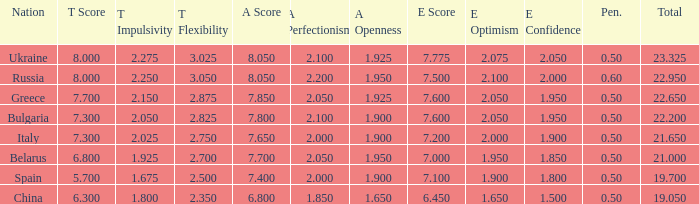What's the sum of A Score that also has a score lower than 7.3 and an E Score larger than 7.1? None. 